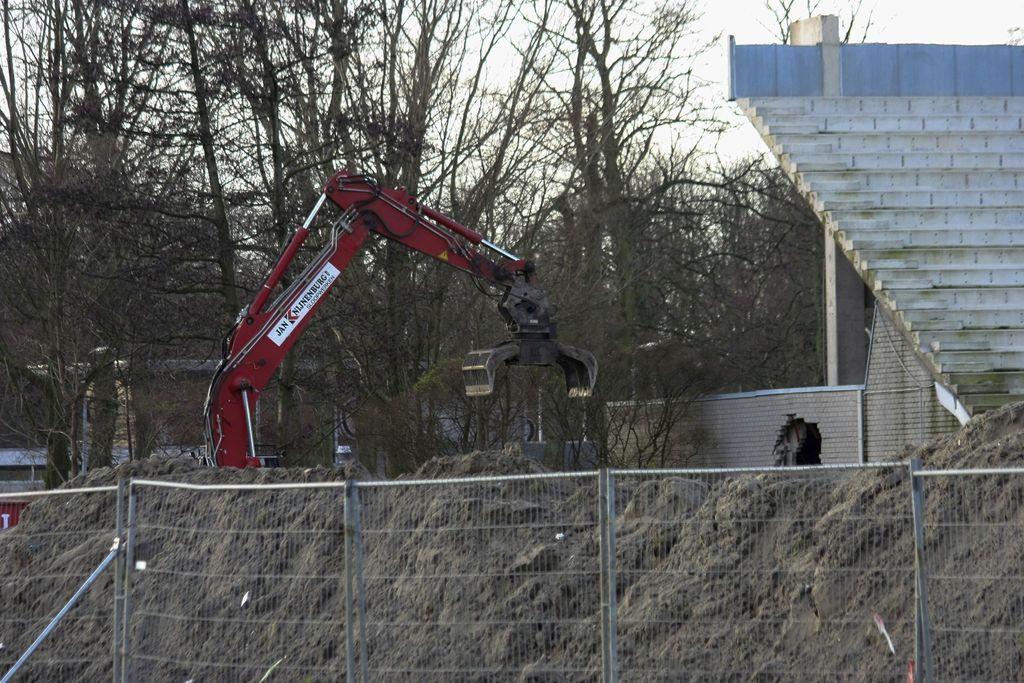Describe this image in one or two sentences. In this image, there is a fencing, at the left side there is a crane, at the right side there are some stairs, at the background there are some trees and at the top there is a sky. 